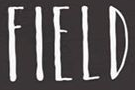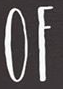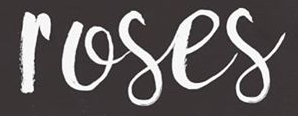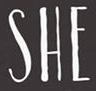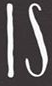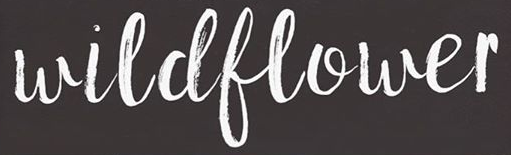What text is displayed in these images sequentially, separated by a semicolon? FIELD; OF; roses; SHE; IS; wildflower 